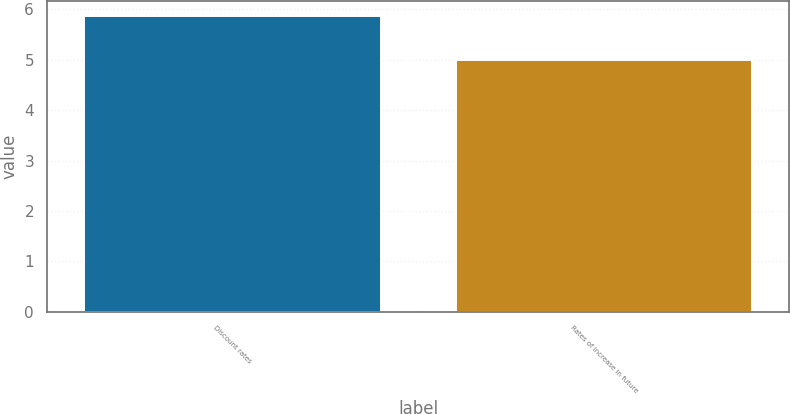Convert chart to OTSL. <chart><loc_0><loc_0><loc_500><loc_500><bar_chart><fcel>Discount rates<fcel>Rates of increase in future<nl><fcel>5.88<fcel>5<nl></chart> 